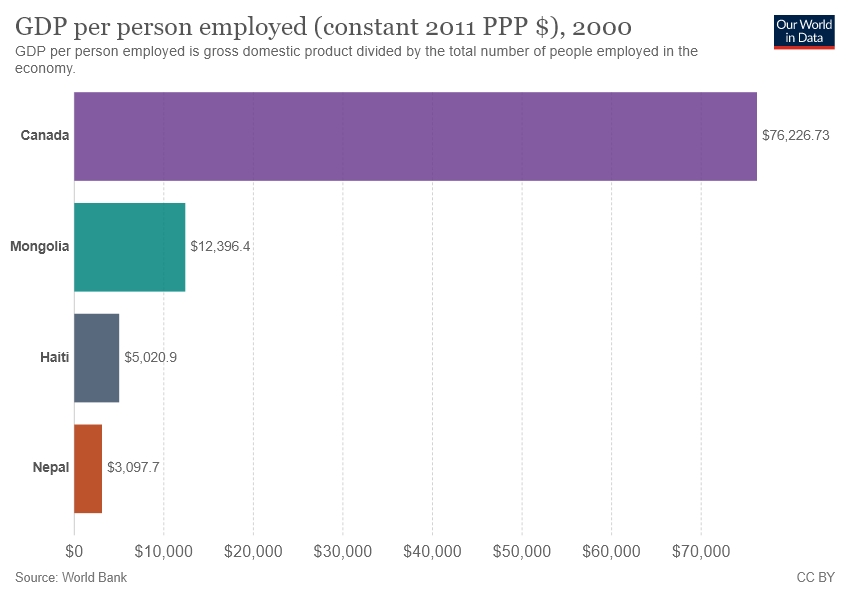Point out several critical features in this image. Canada is approximately 24.6 times larger in size than Nepal, according to data. The bar labeled "Nepal" is red, indicating that Nepal is the country in question. 